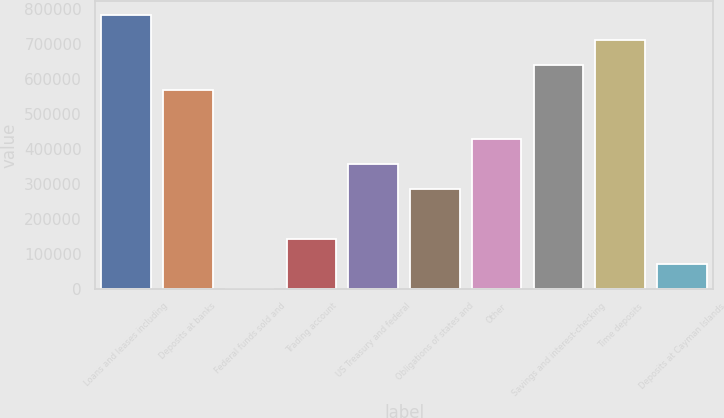Convert chart to OTSL. <chart><loc_0><loc_0><loc_500><loc_500><bar_chart><fcel>Loans and leases including<fcel>Deposits at banks<fcel>Federal funds sold and<fcel>Trading account<fcel>US Treasury and federal<fcel>Obligations of states and<fcel>Other<fcel>Savings and interest-checking<fcel>Time deposits<fcel>Deposits at Cayman Islands<nl><fcel>781207<fcel>568159<fcel>32<fcel>142064<fcel>355112<fcel>284096<fcel>426127<fcel>639175<fcel>710191<fcel>71047.9<nl></chart> 